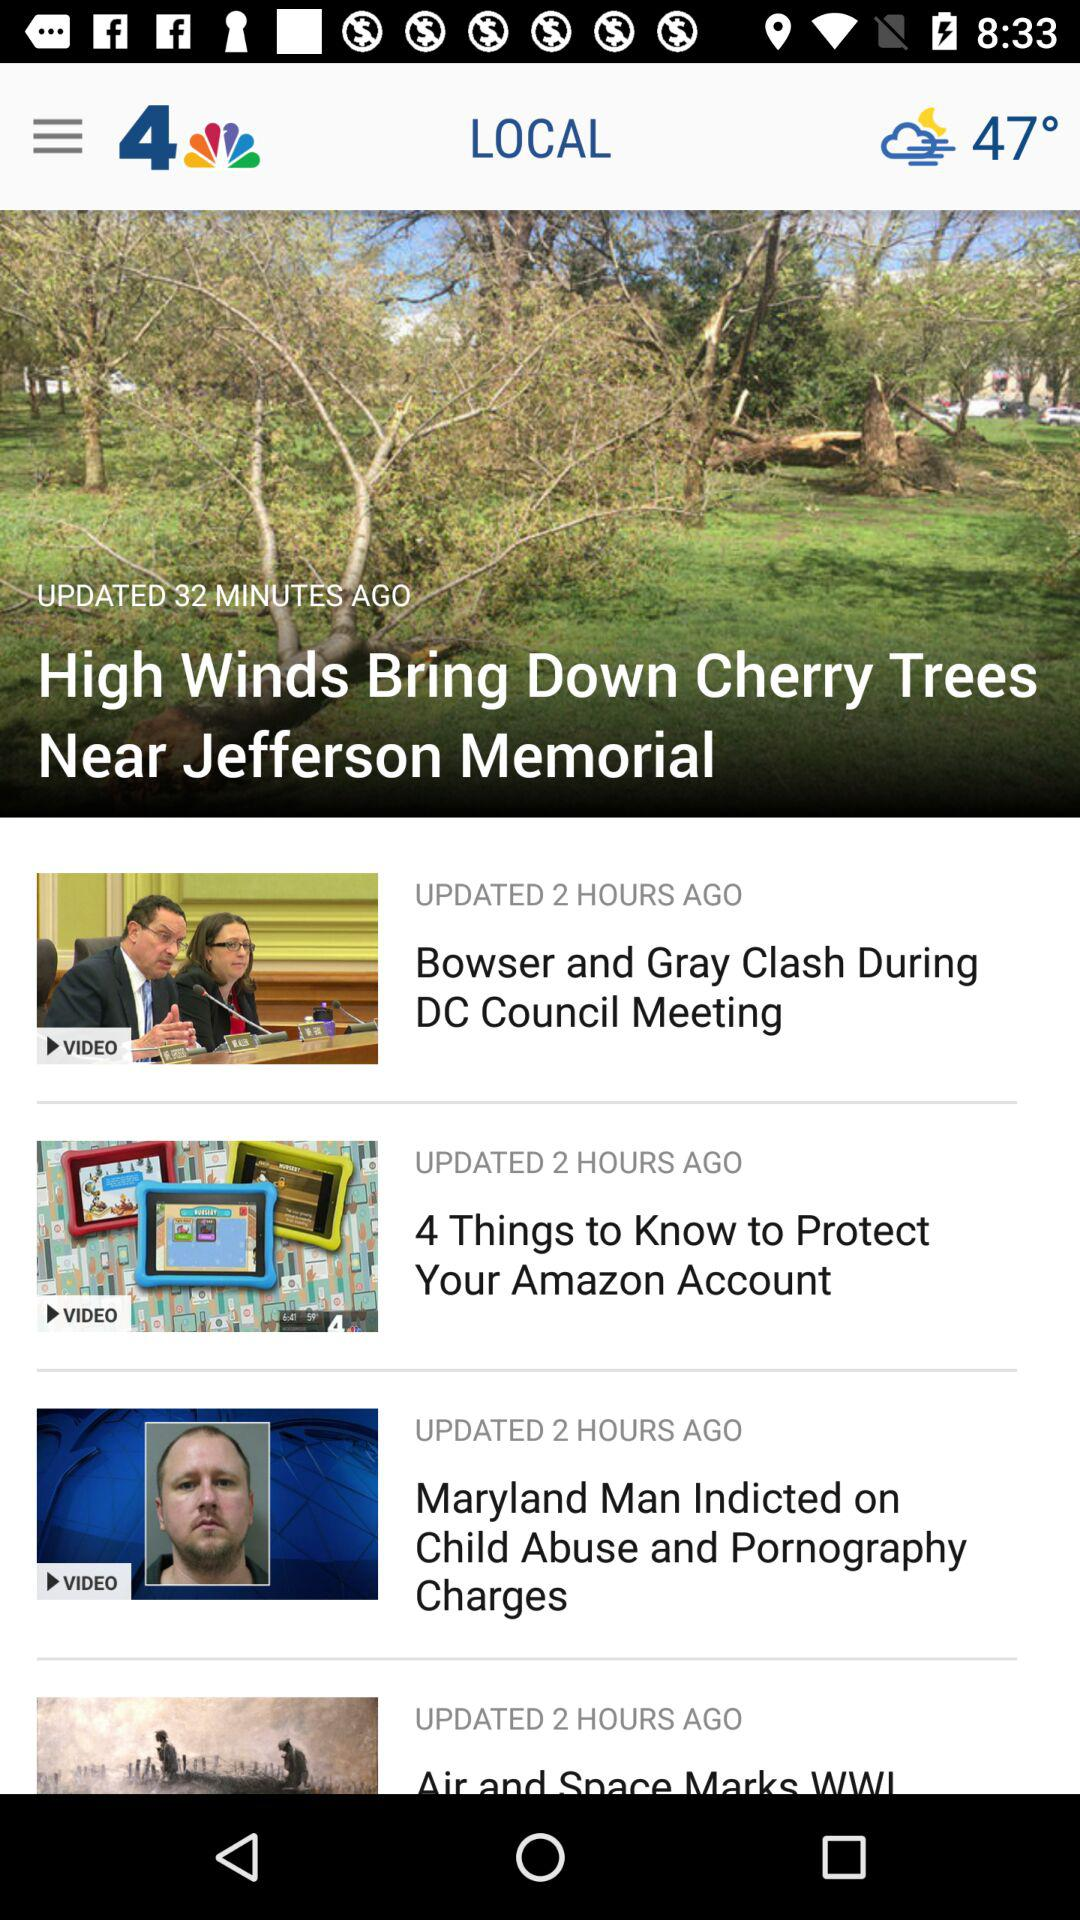When was "High Winds Bring Down Cherry Trees Near Jefferson Memorial" updated? "High Winds Bring Down Cherry Trees Near Jefferson Memorial" was updated 32 minutes ago. 